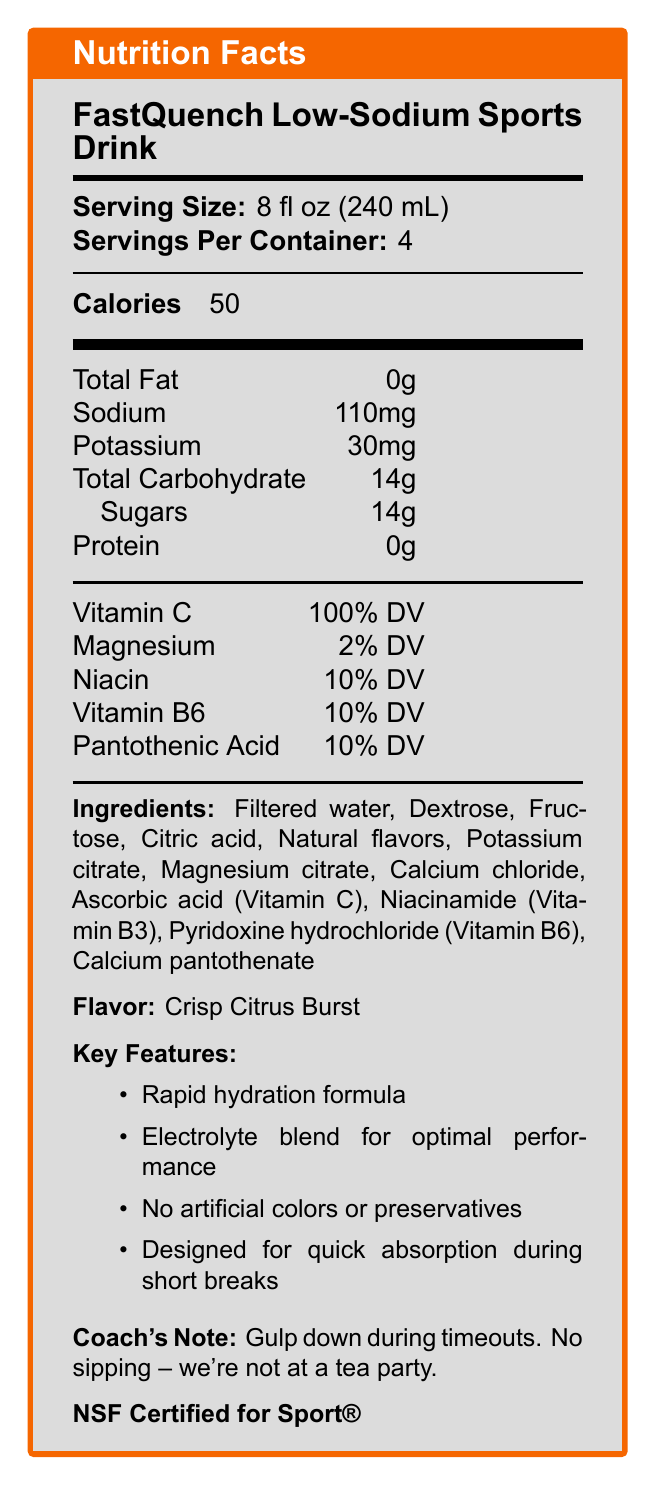what is the serving size of the FastQuench Low-Sodium Sports Drink? The serving size is listed in the Nutrition Facts section as "8 fl oz (240 mL)".
Answer: 8 fl oz (240 mL) how many servings are there per container? The document mentions "Servings Per Container: 4".
Answer: 4 how many calories are in one serving? The number of calories per serving is given as 50 in the Nutrition Facts section.
Answer: 50 how much sodium is in a single serving? The amount of sodium per serving is listed as "110mg".
Answer: 110mg what percent of the daily value of Vitamin C does this drink provide? The Nutrition Facts section indicates that Vitamin C is 100% DV.
Answer: 100% DV which vitamins are present in this sports drink? A. Vitamin A and Vitamin D B. Vitamin C and Vitamin B6 C. Vitamin E and Vitamin K D. Vitamin B12 and Vitamin K The document lists Vitamin C and Vitamin B6 in the Nutrition Facts section.
Answer: B. Vitamin C and Vitamin B6 what is the flavor of the FastQuench Low-Sodium Sports Drink? The flavor is mentioned as "Crisp Citrus Burst" under the Ingredients section.
Answer: Crisp Citrus Burst which feature is NOT listed for the FastQuench sports drink? A. Rapid hydration formula B. Artificial colors C. Electrolyte blend for optimal performance D. Designed for quick absorption during short breaks The key features explicitly state "No artificial colors or preservatives".
Answer: B. Artificial colors is this drink NSF Certified for Sport®? The document explicitly mentions "NSF Certified for Sport®".
Answer: Yes summarize the main features and benefits of FastQuench Low-Sodium Sports Drink. The document highlights FastQuench's rapid hydration, low sodium content, essential vitamins, lack of artificial additives, and certification, making it suitable for high-intensity athletes.
Answer: FastQuench Low-Sodium Sports Drink is designed for rapid hydration during timeouts. It has a low-sodium formula, contains essential vitamins, and has no artificial colors or preservatives. It provides 50 calories per serving, with 110mg of sodium and 14g of sugars. The drink is NSF Certified for Sport®. how many grams of protein does it contain per serving? The Nutrition Facts section lists "Protein: 0g".
Answer: 0g what are the primary ingredients in this drink? The primary ingredients are listed in the document under the Ingredients section.
Answer: Filtered water, Dextrose, Fructose, Citric acid, Natural flavors, Potassium citrate, Magnesium citrate, Calcium chloride, Ascorbic acid (Vitamin C), Niacinamide (Vitamin B3), Pyridoxine hydrochloride (Vitamin B6), Calcium pantothenate what is the magnesium content per serving, based on the daily value percentage? The Nutrition Facts section shows Magnesium at 2% DV.
Answer: 2% DV what is the recommended usage instruction during a game? The usage instructions specifically say to gulp it down during timeouts without sipping.
Answer: Gulp down during timeouts. No sipping – we're not at a tea party. how long is the shelf life of this sports drink? The document mentions a shelf life of 12 months under the shelf-life section.
Answer: 12 months what is the target audience for this drink? The target audience is listed as "High-intensity athletes needing rapid rehydration".
Answer: High-intensity athletes needing rapid rehydration what is the potassium content per serving? The Nutrition Facts section shows that each serving contains 30mg of potassium.
Answer: 30mg is this drink suitable for people allergic to soy and milk? The document indicates it is produced in a facility handling soy and milk products, but it does not confirm suitability for those allergic to soy and milk.
Answer: Not enough information 